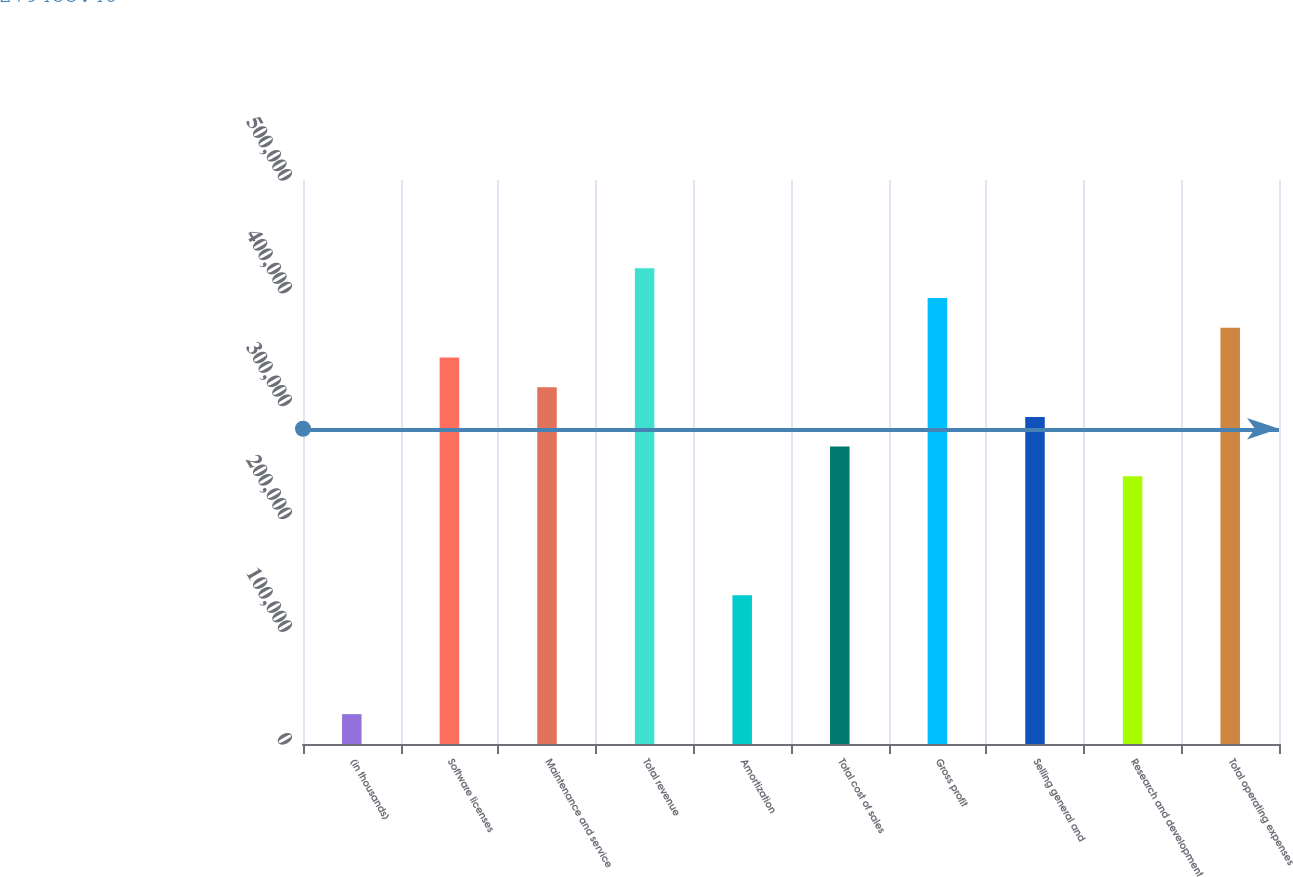<chart> <loc_0><loc_0><loc_500><loc_500><bar_chart><fcel>(in thousands)<fcel>Software licenses<fcel>Maintenance and service<fcel>Total revenue<fcel>Amortization<fcel>Total cost of sales<fcel>Gross profit<fcel>Selling general and<fcel>Research and development<fcel>Total operating expenses<nl><fcel>26437.8<fcel>342707<fcel>316352<fcel>421775<fcel>131861<fcel>263640<fcel>395419<fcel>289996<fcel>237284<fcel>369063<nl></chart> 